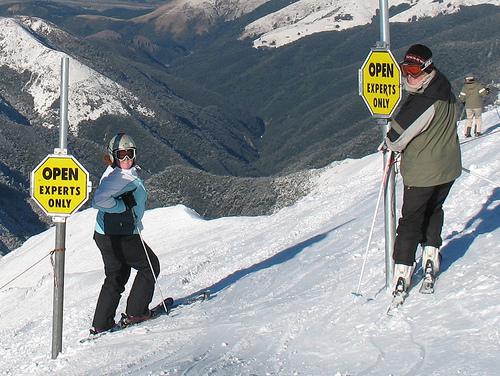Are these women experts?
Give a very brief answer. Yes. Is the terrain flat?
Concise answer only. No. What do the signs say?
Give a very brief answer. Open experts only. 